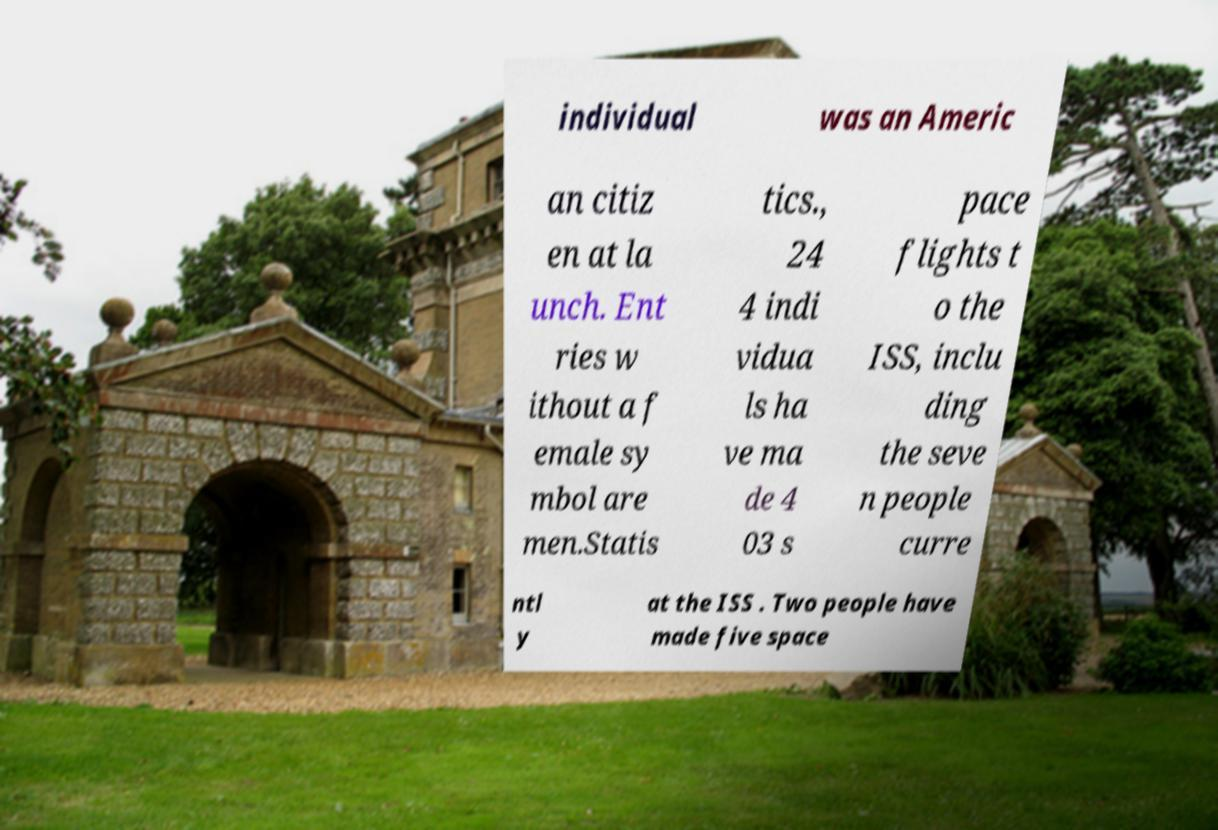Please read and relay the text visible in this image. What does it say? individual was an Americ an citiz en at la unch. Ent ries w ithout a f emale sy mbol are men.Statis tics., 24 4 indi vidua ls ha ve ma de 4 03 s pace flights t o the ISS, inclu ding the seve n people curre ntl y at the ISS . Two people have made five space 